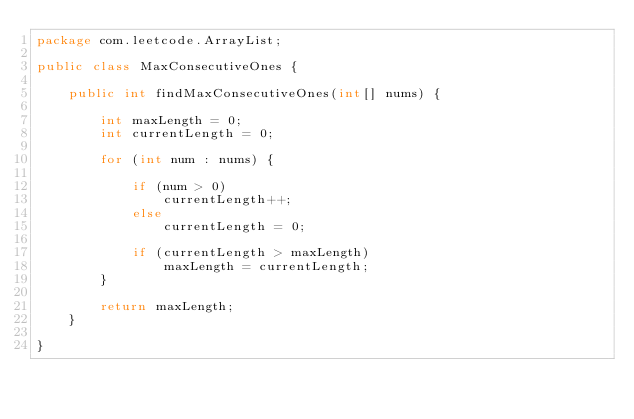Convert code to text. <code><loc_0><loc_0><loc_500><loc_500><_Java_>package com.leetcode.ArrayList;

public class MaxConsecutiveOnes {

    public int findMaxConsecutiveOnes(int[] nums) {

        int maxLength = 0;
        int currentLength = 0;

        for (int num : nums) {

            if (num > 0)
                currentLength++;
            else
                currentLength = 0;

            if (currentLength > maxLength)
                maxLength = currentLength;
        }

        return maxLength;
    }

}
</code> 